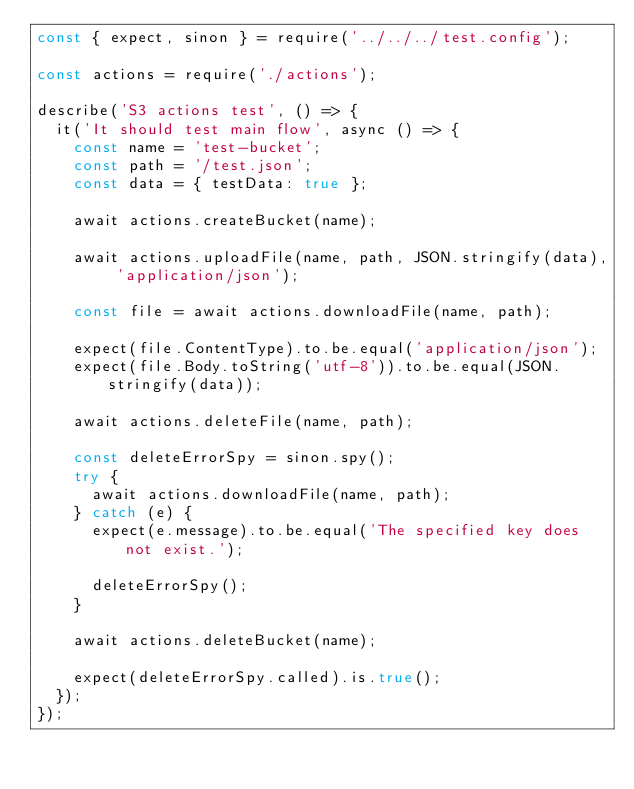<code> <loc_0><loc_0><loc_500><loc_500><_JavaScript_>const { expect, sinon } = require('../../../test.config');

const actions = require('./actions');

describe('S3 actions test', () => {
  it('It should test main flow', async () => {
    const name = 'test-bucket';
    const path = '/test.json';
    const data = { testData: true };

    await actions.createBucket(name);

    await actions.uploadFile(name, path, JSON.stringify(data), 'application/json');

    const file = await actions.downloadFile(name, path);

    expect(file.ContentType).to.be.equal('application/json');
    expect(file.Body.toString('utf-8')).to.be.equal(JSON.stringify(data));

    await actions.deleteFile(name, path);

    const deleteErrorSpy = sinon.spy();
    try {
      await actions.downloadFile(name, path);
    } catch (e) {
      expect(e.message).to.be.equal('The specified key does not exist.');

      deleteErrorSpy();
    }

    await actions.deleteBucket(name);

    expect(deleteErrorSpy.called).is.true();
  });
});
</code> 